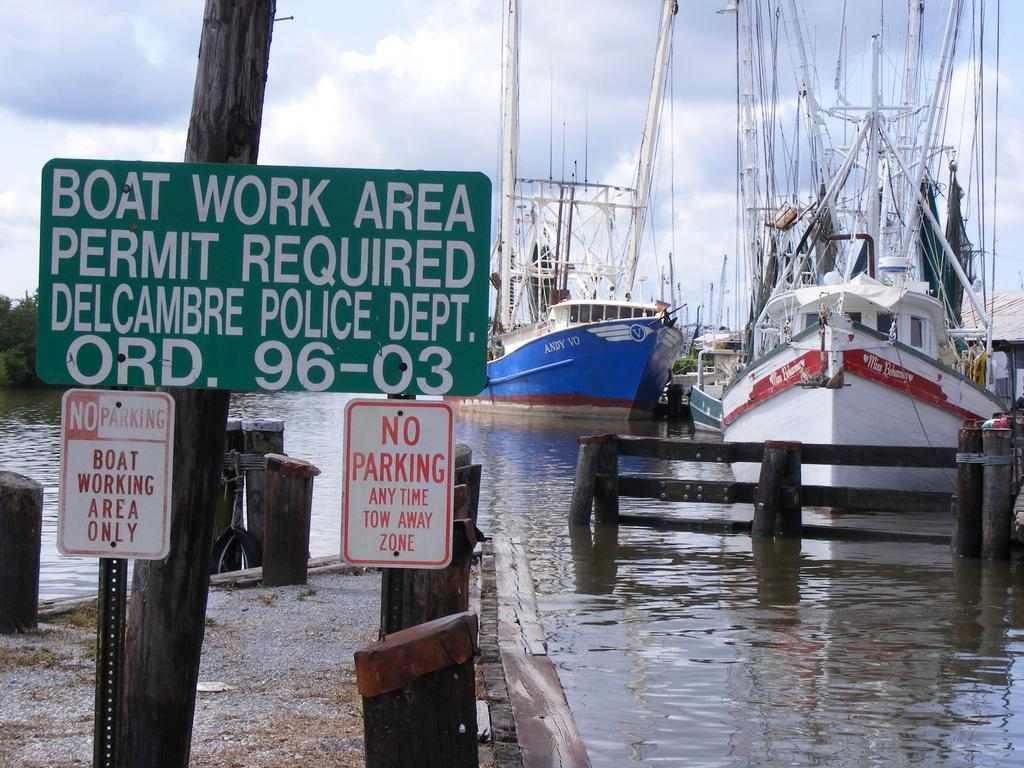What is in the water in the image? There are boats in the water in the image. What else can be seen in the image besides the boats? There are boards with text and trees visible in the image. How would you describe the sky in the image? The sky is cloudy in the image. Can you see any waves in the image? There are no waves visible in the image; it shows boats in the water, but the water's surface appears calm. What type of match is being played in the image? There is no match or any indication of a game being played in the image. 